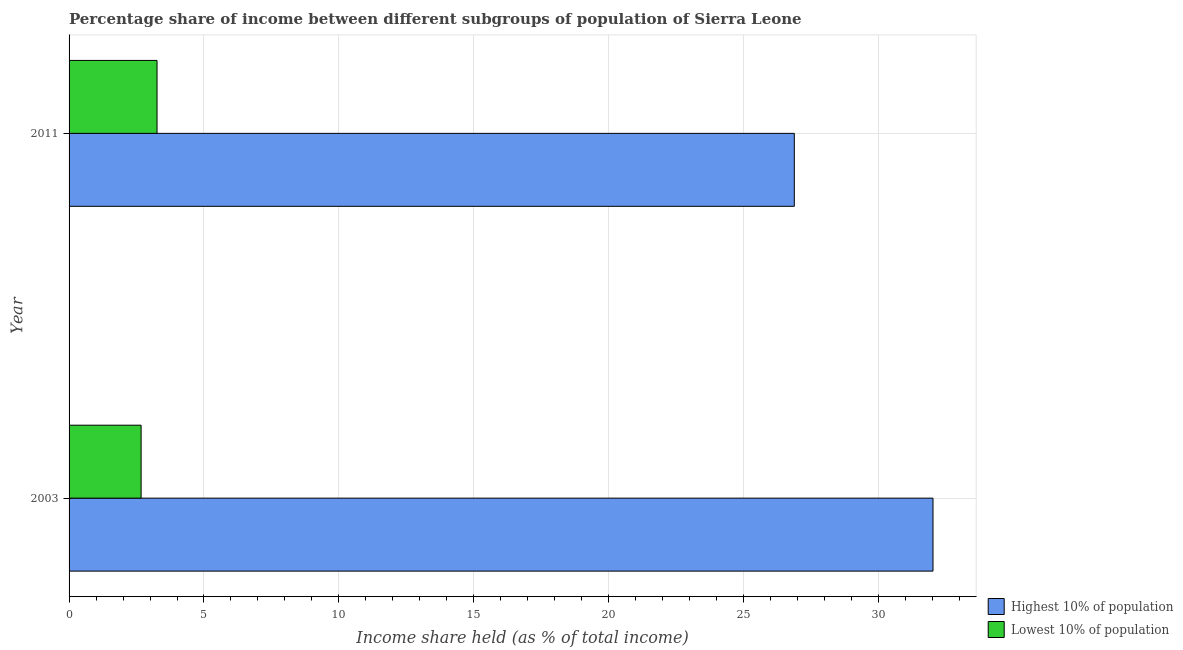Are the number of bars per tick equal to the number of legend labels?
Your response must be concise. Yes. Are the number of bars on each tick of the Y-axis equal?
Provide a succinct answer. Yes. What is the label of the 1st group of bars from the top?
Make the answer very short. 2011. What is the income share held by lowest 10% of the population in 2003?
Provide a short and direct response. 2.67. Across all years, what is the maximum income share held by lowest 10% of the population?
Provide a succinct answer. 3.26. Across all years, what is the minimum income share held by lowest 10% of the population?
Offer a very short reply. 2.67. In which year was the income share held by highest 10% of the population maximum?
Offer a terse response. 2003. What is the total income share held by lowest 10% of the population in the graph?
Make the answer very short. 5.93. What is the difference between the income share held by lowest 10% of the population in 2003 and that in 2011?
Offer a very short reply. -0.59. What is the difference between the income share held by lowest 10% of the population in 2003 and the income share held by highest 10% of the population in 2011?
Offer a terse response. -24.21. What is the average income share held by highest 10% of the population per year?
Keep it short and to the point. 29.45. In the year 2011, what is the difference between the income share held by lowest 10% of the population and income share held by highest 10% of the population?
Offer a very short reply. -23.62. What is the ratio of the income share held by highest 10% of the population in 2003 to that in 2011?
Your answer should be compact. 1.19. Is the difference between the income share held by lowest 10% of the population in 2003 and 2011 greater than the difference between the income share held by highest 10% of the population in 2003 and 2011?
Ensure brevity in your answer.  No. What does the 1st bar from the top in 2011 represents?
Give a very brief answer. Lowest 10% of population. What does the 2nd bar from the bottom in 2003 represents?
Ensure brevity in your answer.  Lowest 10% of population. What is the difference between two consecutive major ticks on the X-axis?
Offer a very short reply. 5. Are the values on the major ticks of X-axis written in scientific E-notation?
Keep it short and to the point. No. How many legend labels are there?
Keep it short and to the point. 2. How are the legend labels stacked?
Ensure brevity in your answer.  Vertical. What is the title of the graph?
Your answer should be very brief. Percentage share of income between different subgroups of population of Sierra Leone. What is the label or title of the X-axis?
Provide a succinct answer. Income share held (as % of total income). What is the label or title of the Y-axis?
Offer a terse response. Year. What is the Income share held (as % of total income) in Highest 10% of population in 2003?
Provide a short and direct response. 32.02. What is the Income share held (as % of total income) in Lowest 10% of population in 2003?
Your answer should be very brief. 2.67. What is the Income share held (as % of total income) in Highest 10% of population in 2011?
Offer a very short reply. 26.88. What is the Income share held (as % of total income) of Lowest 10% of population in 2011?
Provide a succinct answer. 3.26. Across all years, what is the maximum Income share held (as % of total income) in Highest 10% of population?
Offer a terse response. 32.02. Across all years, what is the maximum Income share held (as % of total income) in Lowest 10% of population?
Provide a short and direct response. 3.26. Across all years, what is the minimum Income share held (as % of total income) in Highest 10% of population?
Provide a succinct answer. 26.88. Across all years, what is the minimum Income share held (as % of total income) in Lowest 10% of population?
Your answer should be very brief. 2.67. What is the total Income share held (as % of total income) of Highest 10% of population in the graph?
Ensure brevity in your answer.  58.9. What is the total Income share held (as % of total income) of Lowest 10% of population in the graph?
Offer a terse response. 5.93. What is the difference between the Income share held (as % of total income) in Highest 10% of population in 2003 and that in 2011?
Give a very brief answer. 5.14. What is the difference between the Income share held (as % of total income) in Lowest 10% of population in 2003 and that in 2011?
Keep it short and to the point. -0.59. What is the difference between the Income share held (as % of total income) in Highest 10% of population in 2003 and the Income share held (as % of total income) in Lowest 10% of population in 2011?
Provide a succinct answer. 28.76. What is the average Income share held (as % of total income) of Highest 10% of population per year?
Keep it short and to the point. 29.45. What is the average Income share held (as % of total income) of Lowest 10% of population per year?
Offer a terse response. 2.96. In the year 2003, what is the difference between the Income share held (as % of total income) in Highest 10% of population and Income share held (as % of total income) in Lowest 10% of population?
Your response must be concise. 29.35. In the year 2011, what is the difference between the Income share held (as % of total income) of Highest 10% of population and Income share held (as % of total income) of Lowest 10% of population?
Give a very brief answer. 23.62. What is the ratio of the Income share held (as % of total income) in Highest 10% of population in 2003 to that in 2011?
Offer a terse response. 1.19. What is the ratio of the Income share held (as % of total income) of Lowest 10% of population in 2003 to that in 2011?
Your response must be concise. 0.82. What is the difference between the highest and the second highest Income share held (as % of total income) of Highest 10% of population?
Offer a very short reply. 5.14. What is the difference between the highest and the second highest Income share held (as % of total income) of Lowest 10% of population?
Ensure brevity in your answer.  0.59. What is the difference between the highest and the lowest Income share held (as % of total income) of Highest 10% of population?
Provide a succinct answer. 5.14. What is the difference between the highest and the lowest Income share held (as % of total income) in Lowest 10% of population?
Your answer should be compact. 0.59. 